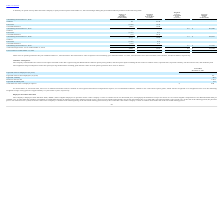From Ringcentral's financial document, What are the respective intrinsic value of options exercised in the year ended December 31, 2019 and 2018? The document shows two values: $215.5 million and $74.6 million. From the document: "g year ended December 31, 2019, 2018 and 2017 were $215.5 million, $74.6 million, and $41.2 million, respectively. ember 31, 2019, 2018 and 2017 were ..." Also, What are the respective intrinsic value of options exercised in the year ended December 31, 2018 and 2017? The document shows two values: $74.6 million and $41.2 million. From the document: "8 and 2017 were $215.5 million, $74.6 million, and $41.2 million, respectively. ember 31, 2019, 2018 and 2017 were $215.5 million, $74.6 million, and ..." Also, What is the weighted average price per share of granted in 2017? According to the financial document, 23.99. The relevant text states: "Granted 25 23.99..." Also, can you calculate: What is the percentage change in the total intrinsic value of options exercised during year ended December 31, 2019 and 2018? To answer this question, I need to perform calculations using the financial data. The calculation is: (215.5 - 74.6)/74.6 , which equals 188.87 (percentage). This is based on the information: "year ended December 31, 2019, 2018 and 2017 were $215.5 million, $74.6 million, and $41.2 million, respectively. ber 31, 2019, 2018 and 2017 were $215.5 million, $74.6 million, and $41.2 million, resp..." The key data points involved are: 215.5, 74.6. Also, can you calculate: What is the average total intrinsic value of options exercised during year ended December 31, 2017 to 2019? To answer this question, I need to perform calculations using the financial data. The calculation is: (215.5 + 74.6 + 41.2)/3 , which equals 110.43 (in millions). This is based on the information: "and 2017 were $215.5 million, $74.6 million, and $41.2 million, respectively. year ended December 31, 2019, 2018 and 2017 were $215.5 million, $74.6 million, and $41.2 million, respectively. ber 31, 2..." The key data points involved are: 215.5, 41.2, 74.6. Also, can you calculate: What is the percentage change in the number of outstanding options between December 31, 2016 and 2017? To answer this question, I need to perform calculations using the financial data. The calculation is: (5,286- 7,384)/ 7,384 , which equals -28.41 (percentage). This is based on the information: "Outstanding at December 31, 2016 7,384 $ 10.59 5.3 $ 74,065 Outstanding at December 31, 2017 5,286 $ 10.30 4.2 $ 201,480..." The key data points involved are: 5,286, 7,384. 